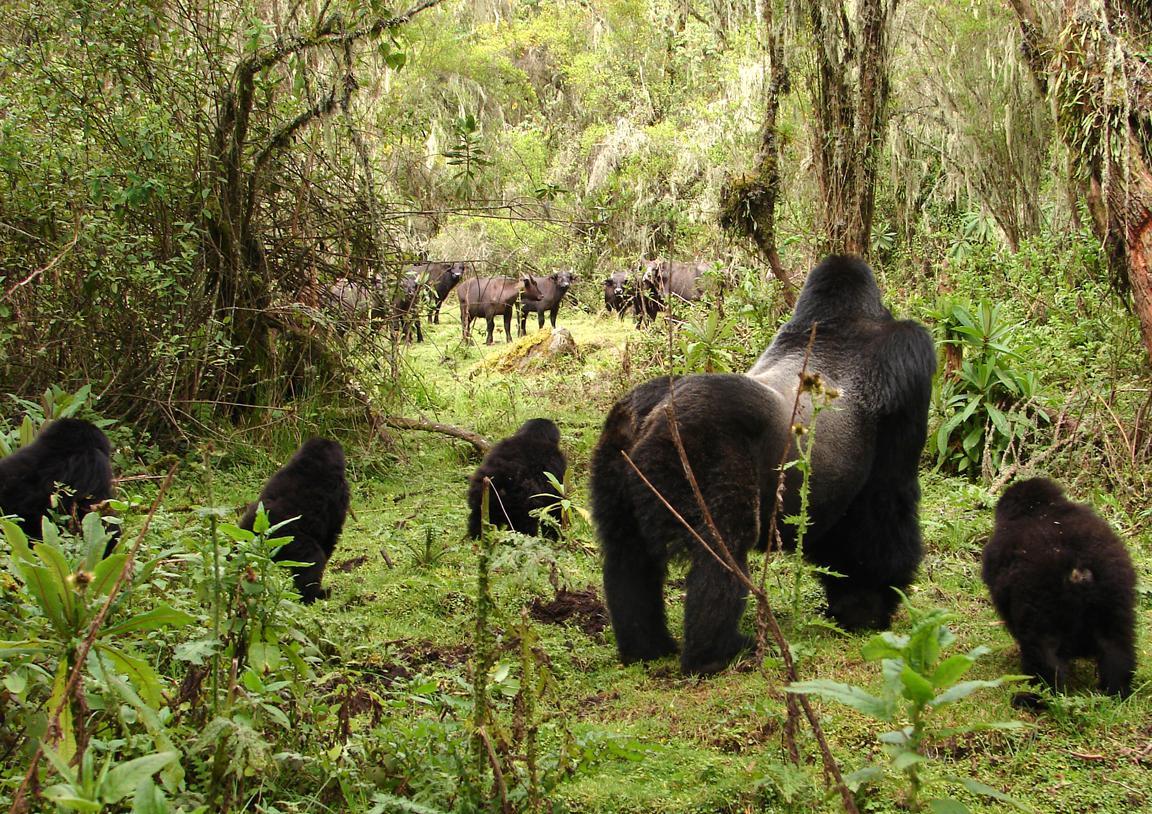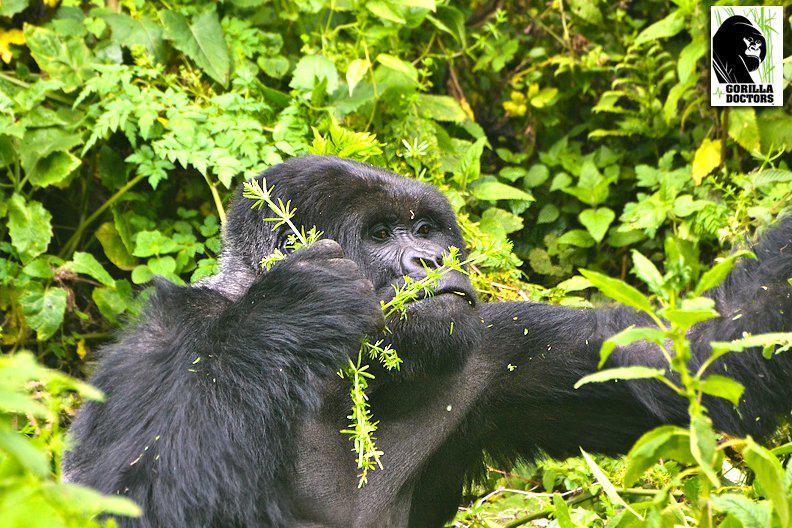The first image is the image on the left, the second image is the image on the right. For the images displayed, is the sentence "The left image includes a rear-facing adult gorilla on all fours, with its body turned rightward and smaller gorillas around it." factually correct? Answer yes or no. Yes. The first image is the image on the left, the second image is the image on the right. For the images displayed, is the sentence "The right image contains no more than one gorilla." factually correct? Answer yes or no. Yes. 